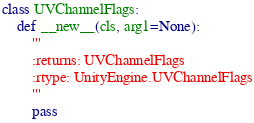<code> <loc_0><loc_0><loc_500><loc_500><_Python_>

class UVChannelFlags:
    def __new__(cls, arg1=None):
        '''
        :returns: UVChannelFlags
        :rtype: UnityEngine.UVChannelFlags
        '''
        pass
</code> 